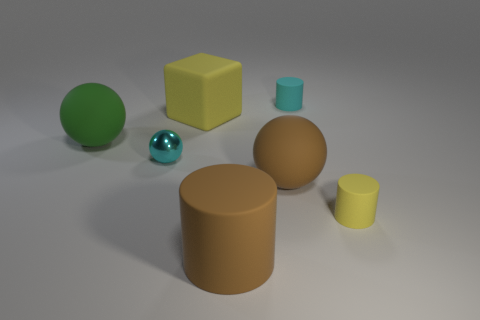There is a large thing that is in front of the rubber thing on the right side of the cyan matte cylinder; what color is it?
Ensure brevity in your answer.  Brown. How many tiny things are cyan shiny cylinders or rubber things?
Offer a terse response. 2. There is a ball that is both right of the big green rubber object and on the left side of the cube; what is its color?
Provide a succinct answer. Cyan. Is the material of the large yellow block the same as the tiny yellow thing?
Your answer should be compact. Yes. The small yellow thing has what shape?
Give a very brief answer. Cylinder. What number of yellow objects are behind the sphere that is in front of the small cyan metallic ball that is behind the large brown matte ball?
Make the answer very short. 1. What is the color of the large matte object that is the same shape as the tiny yellow rubber object?
Your answer should be compact. Brown. The cyan thing on the right side of the rubber sphere right of the big rubber sphere that is behind the cyan metal object is what shape?
Ensure brevity in your answer.  Cylinder. How big is the matte cylinder that is right of the big cylinder and in front of the cyan metal object?
Ensure brevity in your answer.  Small. Is the number of cyan matte cylinders less than the number of gray metal cylinders?
Ensure brevity in your answer.  No. 